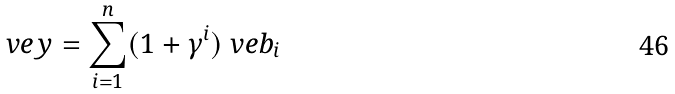<formula> <loc_0><loc_0><loc_500><loc_500>\ v e y = \sum _ { i = 1 } ^ { n } ( 1 + \gamma ^ { i } ) \ v e b _ { i }</formula> 